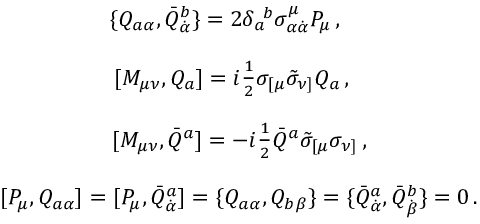Convert formula to latex. <formula><loc_0><loc_0><loc_500><loc_500>\begin{array} { c } { { \{ Q _ { a \alpha } , \bar { Q } _ { \dot { \alpha } } ^ { b } \} = 2 \delta _ { a } ^ { b } \sigma _ { \alpha \dot { \alpha } } ^ { \mu } P _ { \mu } \, , } } \\ { [ M _ { \mu \nu } , Q _ { a } ] = i \frac { 1 } { 2 } \sigma _ { [ \mu } \tilde { \sigma } _ { \nu ] } Q _ { a } \, , } } \\ { [ M _ { \mu \nu } , \bar { Q } ^ { a } ] = - i \frac { 1 } { 2 } \bar { Q } ^ { a } \tilde { \sigma } _ { [ \mu } \sigma _ { \nu ] } \, , } } \\ { [ { P } _ { \mu } , Q _ { a \alpha } ] = [ P _ { \mu } , \bar { Q } _ { \dot { \alpha } } ^ { a } ] = \{ Q _ { a \alpha } , Q _ { b \beta } \} = \{ \bar { Q } _ { \dot { \alpha } } ^ { a } , \bar { Q } _ { \dot { \beta } } ^ { b } \} = 0 \, . } } \end{array}</formula> 